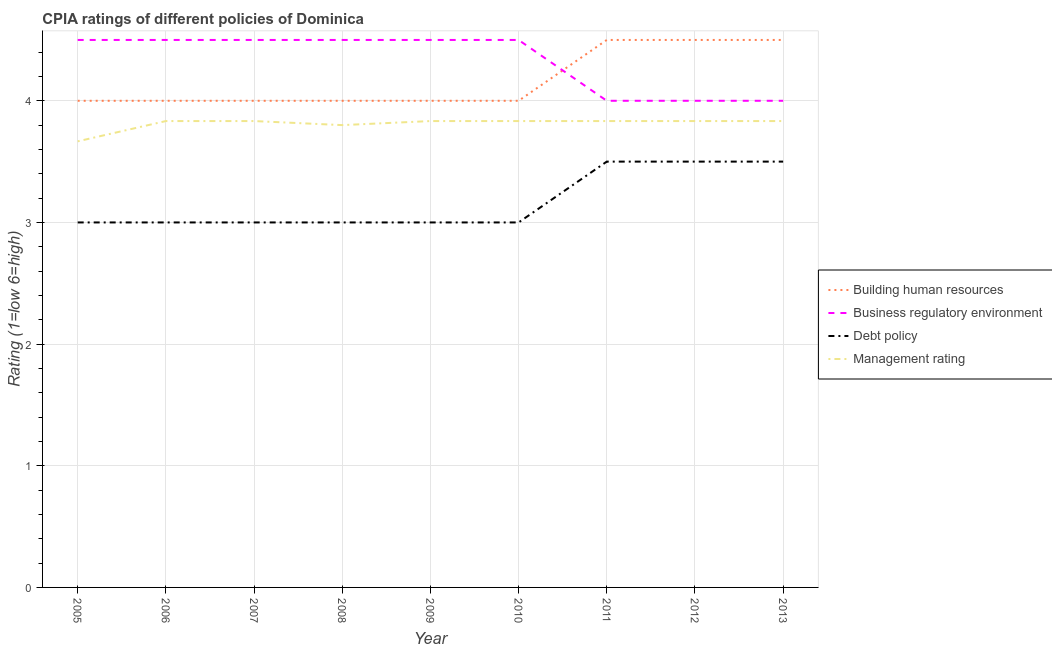Does the line corresponding to cpia rating of management intersect with the line corresponding to cpia rating of debt policy?
Offer a very short reply. No. Is the number of lines equal to the number of legend labels?
Provide a succinct answer. Yes. Across all years, what is the minimum cpia rating of business regulatory environment?
Make the answer very short. 4. What is the total cpia rating of building human resources in the graph?
Give a very brief answer. 37.5. What is the difference between the cpia rating of management in 2008 and the cpia rating of debt policy in 2013?
Offer a very short reply. 0.3. What is the average cpia rating of management per year?
Your answer should be very brief. 3.81. In the year 2012, what is the difference between the cpia rating of building human resources and cpia rating of management?
Ensure brevity in your answer.  0.67. What is the ratio of the cpia rating of management in 2008 to that in 2011?
Keep it short and to the point. 0.99. Is the cpia rating of debt policy in 2007 less than that in 2008?
Keep it short and to the point. No. Is the difference between the cpia rating of management in 2007 and 2008 greater than the difference between the cpia rating of business regulatory environment in 2007 and 2008?
Offer a very short reply. Yes. Is it the case that in every year, the sum of the cpia rating of debt policy and cpia rating of management is greater than the sum of cpia rating of business regulatory environment and cpia rating of building human resources?
Offer a very short reply. No. Is it the case that in every year, the sum of the cpia rating of building human resources and cpia rating of business regulatory environment is greater than the cpia rating of debt policy?
Give a very brief answer. Yes. Does the cpia rating of business regulatory environment monotonically increase over the years?
Keep it short and to the point. No. Is the cpia rating of management strictly less than the cpia rating of debt policy over the years?
Offer a very short reply. No. How many lines are there?
Your answer should be compact. 4. Does the graph contain any zero values?
Provide a succinct answer. No. Does the graph contain grids?
Your answer should be compact. Yes. Where does the legend appear in the graph?
Offer a terse response. Center right. How many legend labels are there?
Provide a short and direct response. 4. What is the title of the graph?
Ensure brevity in your answer.  CPIA ratings of different policies of Dominica. Does "Austria" appear as one of the legend labels in the graph?
Offer a terse response. No. What is the Rating (1=low 6=high) in Building human resources in 2005?
Ensure brevity in your answer.  4. What is the Rating (1=low 6=high) of Management rating in 2005?
Provide a succinct answer. 3.67. What is the Rating (1=low 6=high) of Management rating in 2006?
Your response must be concise. 3.83. What is the Rating (1=low 6=high) in Debt policy in 2007?
Your answer should be very brief. 3. What is the Rating (1=low 6=high) of Management rating in 2007?
Your answer should be very brief. 3.83. What is the Rating (1=low 6=high) of Building human resources in 2008?
Your answer should be compact. 4. What is the Rating (1=low 6=high) of Debt policy in 2008?
Your answer should be compact. 3. What is the Rating (1=low 6=high) of Business regulatory environment in 2009?
Ensure brevity in your answer.  4.5. What is the Rating (1=low 6=high) in Debt policy in 2009?
Your response must be concise. 3. What is the Rating (1=low 6=high) in Management rating in 2009?
Your response must be concise. 3.83. What is the Rating (1=low 6=high) of Management rating in 2010?
Offer a very short reply. 3.83. What is the Rating (1=low 6=high) in Building human resources in 2011?
Offer a very short reply. 4.5. What is the Rating (1=low 6=high) in Management rating in 2011?
Offer a very short reply. 3.83. What is the Rating (1=low 6=high) in Building human resources in 2012?
Ensure brevity in your answer.  4.5. What is the Rating (1=low 6=high) of Management rating in 2012?
Your answer should be compact. 3.83. What is the Rating (1=low 6=high) of Debt policy in 2013?
Give a very brief answer. 3.5. What is the Rating (1=low 6=high) in Management rating in 2013?
Your answer should be compact. 3.83. Across all years, what is the maximum Rating (1=low 6=high) of Building human resources?
Provide a short and direct response. 4.5. Across all years, what is the maximum Rating (1=low 6=high) of Management rating?
Provide a short and direct response. 3.83. Across all years, what is the minimum Rating (1=low 6=high) of Building human resources?
Make the answer very short. 4. Across all years, what is the minimum Rating (1=low 6=high) in Debt policy?
Offer a terse response. 3. Across all years, what is the minimum Rating (1=low 6=high) in Management rating?
Ensure brevity in your answer.  3.67. What is the total Rating (1=low 6=high) of Building human resources in the graph?
Ensure brevity in your answer.  37.5. What is the total Rating (1=low 6=high) in Business regulatory environment in the graph?
Provide a short and direct response. 39. What is the total Rating (1=low 6=high) in Debt policy in the graph?
Ensure brevity in your answer.  28.5. What is the total Rating (1=low 6=high) of Management rating in the graph?
Your response must be concise. 34.3. What is the difference between the Rating (1=low 6=high) of Management rating in 2005 and that in 2006?
Your response must be concise. -0.17. What is the difference between the Rating (1=low 6=high) in Building human resources in 2005 and that in 2007?
Your answer should be very brief. 0. What is the difference between the Rating (1=low 6=high) in Building human resources in 2005 and that in 2008?
Your answer should be compact. 0. What is the difference between the Rating (1=low 6=high) of Business regulatory environment in 2005 and that in 2008?
Provide a short and direct response. 0. What is the difference between the Rating (1=low 6=high) of Debt policy in 2005 and that in 2008?
Give a very brief answer. 0. What is the difference between the Rating (1=low 6=high) of Management rating in 2005 and that in 2008?
Your answer should be compact. -0.13. What is the difference between the Rating (1=low 6=high) of Building human resources in 2005 and that in 2009?
Provide a short and direct response. 0. What is the difference between the Rating (1=low 6=high) of Business regulatory environment in 2005 and that in 2009?
Your response must be concise. 0. What is the difference between the Rating (1=low 6=high) of Debt policy in 2005 and that in 2009?
Keep it short and to the point. 0. What is the difference between the Rating (1=low 6=high) in Business regulatory environment in 2005 and that in 2010?
Your answer should be compact. 0. What is the difference between the Rating (1=low 6=high) of Business regulatory environment in 2005 and that in 2011?
Offer a very short reply. 0.5. What is the difference between the Rating (1=low 6=high) of Debt policy in 2005 and that in 2011?
Provide a short and direct response. -0.5. What is the difference between the Rating (1=low 6=high) of Management rating in 2005 and that in 2011?
Offer a very short reply. -0.17. What is the difference between the Rating (1=low 6=high) in Building human resources in 2005 and that in 2012?
Give a very brief answer. -0.5. What is the difference between the Rating (1=low 6=high) in Debt policy in 2005 and that in 2012?
Make the answer very short. -0.5. What is the difference between the Rating (1=low 6=high) in Debt policy in 2005 and that in 2013?
Provide a short and direct response. -0.5. What is the difference between the Rating (1=low 6=high) of Business regulatory environment in 2006 and that in 2007?
Provide a short and direct response. 0. What is the difference between the Rating (1=low 6=high) of Management rating in 2006 and that in 2007?
Offer a terse response. 0. What is the difference between the Rating (1=low 6=high) in Management rating in 2006 and that in 2008?
Offer a terse response. 0.03. What is the difference between the Rating (1=low 6=high) of Management rating in 2006 and that in 2009?
Keep it short and to the point. 0. What is the difference between the Rating (1=low 6=high) of Business regulatory environment in 2006 and that in 2010?
Offer a terse response. 0. What is the difference between the Rating (1=low 6=high) in Debt policy in 2006 and that in 2010?
Ensure brevity in your answer.  0. What is the difference between the Rating (1=low 6=high) in Management rating in 2006 and that in 2010?
Offer a very short reply. 0. What is the difference between the Rating (1=low 6=high) in Debt policy in 2006 and that in 2011?
Provide a short and direct response. -0.5. What is the difference between the Rating (1=low 6=high) in Business regulatory environment in 2006 and that in 2012?
Provide a short and direct response. 0.5. What is the difference between the Rating (1=low 6=high) in Debt policy in 2006 and that in 2012?
Offer a terse response. -0.5. What is the difference between the Rating (1=low 6=high) in Building human resources in 2006 and that in 2013?
Your answer should be compact. -0.5. What is the difference between the Rating (1=low 6=high) of Building human resources in 2007 and that in 2008?
Your response must be concise. 0. What is the difference between the Rating (1=low 6=high) of Business regulatory environment in 2007 and that in 2008?
Your answer should be very brief. 0. What is the difference between the Rating (1=low 6=high) in Debt policy in 2007 and that in 2008?
Provide a short and direct response. 0. What is the difference between the Rating (1=low 6=high) of Building human resources in 2007 and that in 2009?
Make the answer very short. 0. What is the difference between the Rating (1=low 6=high) of Debt policy in 2007 and that in 2009?
Give a very brief answer. 0. What is the difference between the Rating (1=low 6=high) of Management rating in 2007 and that in 2009?
Offer a terse response. 0. What is the difference between the Rating (1=low 6=high) of Building human resources in 2007 and that in 2010?
Your answer should be compact. 0. What is the difference between the Rating (1=low 6=high) of Building human resources in 2007 and that in 2011?
Your answer should be very brief. -0.5. What is the difference between the Rating (1=low 6=high) in Business regulatory environment in 2007 and that in 2013?
Give a very brief answer. 0.5. What is the difference between the Rating (1=low 6=high) in Debt policy in 2007 and that in 2013?
Provide a short and direct response. -0.5. What is the difference between the Rating (1=low 6=high) of Management rating in 2007 and that in 2013?
Your answer should be compact. 0. What is the difference between the Rating (1=low 6=high) of Debt policy in 2008 and that in 2009?
Ensure brevity in your answer.  0. What is the difference between the Rating (1=low 6=high) of Management rating in 2008 and that in 2009?
Your answer should be compact. -0.03. What is the difference between the Rating (1=low 6=high) in Business regulatory environment in 2008 and that in 2010?
Keep it short and to the point. 0. What is the difference between the Rating (1=low 6=high) in Debt policy in 2008 and that in 2010?
Make the answer very short. 0. What is the difference between the Rating (1=low 6=high) in Management rating in 2008 and that in 2010?
Provide a succinct answer. -0.03. What is the difference between the Rating (1=low 6=high) in Management rating in 2008 and that in 2011?
Ensure brevity in your answer.  -0.03. What is the difference between the Rating (1=low 6=high) of Management rating in 2008 and that in 2012?
Provide a succinct answer. -0.03. What is the difference between the Rating (1=low 6=high) in Building human resources in 2008 and that in 2013?
Make the answer very short. -0.5. What is the difference between the Rating (1=low 6=high) in Management rating in 2008 and that in 2013?
Offer a very short reply. -0.03. What is the difference between the Rating (1=low 6=high) of Business regulatory environment in 2009 and that in 2010?
Provide a short and direct response. 0. What is the difference between the Rating (1=low 6=high) of Management rating in 2009 and that in 2010?
Ensure brevity in your answer.  0. What is the difference between the Rating (1=low 6=high) of Building human resources in 2009 and that in 2011?
Provide a succinct answer. -0.5. What is the difference between the Rating (1=low 6=high) in Business regulatory environment in 2009 and that in 2011?
Provide a short and direct response. 0.5. What is the difference between the Rating (1=low 6=high) of Debt policy in 2009 and that in 2011?
Provide a succinct answer. -0.5. What is the difference between the Rating (1=low 6=high) in Building human resources in 2009 and that in 2012?
Make the answer very short. -0.5. What is the difference between the Rating (1=low 6=high) in Debt policy in 2009 and that in 2012?
Ensure brevity in your answer.  -0.5. What is the difference between the Rating (1=low 6=high) of Building human resources in 2009 and that in 2013?
Provide a succinct answer. -0.5. What is the difference between the Rating (1=low 6=high) of Management rating in 2009 and that in 2013?
Offer a terse response. 0. What is the difference between the Rating (1=low 6=high) of Building human resources in 2010 and that in 2011?
Ensure brevity in your answer.  -0.5. What is the difference between the Rating (1=low 6=high) in Business regulatory environment in 2010 and that in 2011?
Provide a succinct answer. 0.5. What is the difference between the Rating (1=low 6=high) in Management rating in 2010 and that in 2011?
Give a very brief answer. 0. What is the difference between the Rating (1=low 6=high) of Building human resources in 2010 and that in 2012?
Your response must be concise. -0.5. What is the difference between the Rating (1=low 6=high) in Debt policy in 2010 and that in 2012?
Give a very brief answer. -0.5. What is the difference between the Rating (1=low 6=high) in Business regulatory environment in 2010 and that in 2013?
Your response must be concise. 0.5. What is the difference between the Rating (1=low 6=high) in Debt policy in 2010 and that in 2013?
Your response must be concise. -0.5. What is the difference between the Rating (1=low 6=high) in Building human resources in 2011 and that in 2012?
Provide a succinct answer. 0. What is the difference between the Rating (1=low 6=high) of Management rating in 2011 and that in 2012?
Offer a terse response. 0. What is the difference between the Rating (1=low 6=high) in Building human resources in 2005 and the Rating (1=low 6=high) in Debt policy in 2006?
Provide a short and direct response. 1. What is the difference between the Rating (1=low 6=high) of Business regulatory environment in 2005 and the Rating (1=low 6=high) of Debt policy in 2006?
Provide a succinct answer. 1.5. What is the difference between the Rating (1=low 6=high) in Business regulatory environment in 2005 and the Rating (1=low 6=high) in Management rating in 2006?
Make the answer very short. 0.67. What is the difference between the Rating (1=low 6=high) of Building human resources in 2005 and the Rating (1=low 6=high) of Business regulatory environment in 2007?
Offer a terse response. -0.5. What is the difference between the Rating (1=low 6=high) in Business regulatory environment in 2005 and the Rating (1=low 6=high) in Debt policy in 2007?
Give a very brief answer. 1.5. What is the difference between the Rating (1=low 6=high) in Business regulatory environment in 2005 and the Rating (1=low 6=high) in Management rating in 2007?
Offer a very short reply. 0.67. What is the difference between the Rating (1=low 6=high) of Building human resources in 2005 and the Rating (1=low 6=high) of Debt policy in 2008?
Provide a short and direct response. 1. What is the difference between the Rating (1=low 6=high) in Building human resources in 2005 and the Rating (1=low 6=high) in Management rating in 2008?
Your answer should be very brief. 0.2. What is the difference between the Rating (1=low 6=high) of Business regulatory environment in 2005 and the Rating (1=low 6=high) of Management rating in 2008?
Give a very brief answer. 0.7. What is the difference between the Rating (1=low 6=high) of Building human resources in 2005 and the Rating (1=low 6=high) of Debt policy in 2009?
Provide a short and direct response. 1. What is the difference between the Rating (1=low 6=high) of Business regulatory environment in 2005 and the Rating (1=low 6=high) of Debt policy in 2009?
Ensure brevity in your answer.  1.5. What is the difference between the Rating (1=low 6=high) of Business regulatory environment in 2005 and the Rating (1=low 6=high) of Debt policy in 2010?
Provide a short and direct response. 1.5. What is the difference between the Rating (1=low 6=high) in Debt policy in 2005 and the Rating (1=low 6=high) in Management rating in 2010?
Offer a very short reply. -0.83. What is the difference between the Rating (1=low 6=high) of Building human resources in 2005 and the Rating (1=low 6=high) of Business regulatory environment in 2011?
Ensure brevity in your answer.  0. What is the difference between the Rating (1=low 6=high) of Building human resources in 2005 and the Rating (1=low 6=high) of Debt policy in 2011?
Provide a succinct answer. 0.5. What is the difference between the Rating (1=low 6=high) in Building human resources in 2005 and the Rating (1=low 6=high) in Management rating in 2011?
Your answer should be compact. 0.17. What is the difference between the Rating (1=low 6=high) of Business regulatory environment in 2005 and the Rating (1=low 6=high) of Management rating in 2011?
Your answer should be compact. 0.67. What is the difference between the Rating (1=low 6=high) in Debt policy in 2005 and the Rating (1=low 6=high) in Management rating in 2011?
Your answer should be very brief. -0.83. What is the difference between the Rating (1=low 6=high) in Building human resources in 2005 and the Rating (1=low 6=high) in Management rating in 2012?
Keep it short and to the point. 0.17. What is the difference between the Rating (1=low 6=high) in Business regulatory environment in 2005 and the Rating (1=low 6=high) in Debt policy in 2012?
Offer a terse response. 1. What is the difference between the Rating (1=low 6=high) in Business regulatory environment in 2005 and the Rating (1=low 6=high) in Management rating in 2012?
Provide a short and direct response. 0.67. What is the difference between the Rating (1=low 6=high) in Building human resources in 2005 and the Rating (1=low 6=high) in Business regulatory environment in 2013?
Offer a terse response. 0. What is the difference between the Rating (1=low 6=high) in Building human resources in 2005 and the Rating (1=low 6=high) in Management rating in 2013?
Provide a succinct answer. 0.17. What is the difference between the Rating (1=low 6=high) in Business regulatory environment in 2005 and the Rating (1=low 6=high) in Debt policy in 2013?
Ensure brevity in your answer.  1. What is the difference between the Rating (1=low 6=high) of Business regulatory environment in 2005 and the Rating (1=low 6=high) of Management rating in 2013?
Make the answer very short. 0.67. What is the difference between the Rating (1=low 6=high) in Building human resources in 2006 and the Rating (1=low 6=high) in Business regulatory environment in 2007?
Ensure brevity in your answer.  -0.5. What is the difference between the Rating (1=low 6=high) of Building human resources in 2006 and the Rating (1=low 6=high) of Debt policy in 2007?
Ensure brevity in your answer.  1. What is the difference between the Rating (1=low 6=high) in Debt policy in 2006 and the Rating (1=low 6=high) in Management rating in 2007?
Your response must be concise. -0.83. What is the difference between the Rating (1=low 6=high) in Business regulatory environment in 2006 and the Rating (1=low 6=high) in Management rating in 2008?
Ensure brevity in your answer.  0.7. What is the difference between the Rating (1=low 6=high) of Debt policy in 2006 and the Rating (1=low 6=high) of Management rating in 2008?
Offer a terse response. -0.8. What is the difference between the Rating (1=low 6=high) in Building human resources in 2006 and the Rating (1=low 6=high) in Business regulatory environment in 2009?
Your answer should be very brief. -0.5. What is the difference between the Rating (1=low 6=high) of Building human resources in 2006 and the Rating (1=low 6=high) of Debt policy in 2009?
Offer a very short reply. 1. What is the difference between the Rating (1=low 6=high) in Building human resources in 2006 and the Rating (1=low 6=high) in Management rating in 2009?
Your answer should be very brief. 0.17. What is the difference between the Rating (1=low 6=high) in Business regulatory environment in 2006 and the Rating (1=low 6=high) in Debt policy in 2009?
Your response must be concise. 1.5. What is the difference between the Rating (1=low 6=high) of Building human resources in 2006 and the Rating (1=low 6=high) of Business regulatory environment in 2010?
Your response must be concise. -0.5. What is the difference between the Rating (1=low 6=high) in Building human resources in 2006 and the Rating (1=low 6=high) in Debt policy in 2010?
Ensure brevity in your answer.  1. What is the difference between the Rating (1=low 6=high) in Business regulatory environment in 2006 and the Rating (1=low 6=high) in Debt policy in 2010?
Ensure brevity in your answer.  1.5. What is the difference between the Rating (1=low 6=high) in Debt policy in 2006 and the Rating (1=low 6=high) in Management rating in 2010?
Keep it short and to the point. -0.83. What is the difference between the Rating (1=low 6=high) in Building human resources in 2006 and the Rating (1=low 6=high) in Business regulatory environment in 2011?
Your answer should be very brief. 0. What is the difference between the Rating (1=low 6=high) of Building human resources in 2006 and the Rating (1=low 6=high) of Debt policy in 2011?
Provide a succinct answer. 0.5. What is the difference between the Rating (1=low 6=high) of Building human resources in 2006 and the Rating (1=low 6=high) of Management rating in 2011?
Your answer should be compact. 0.17. What is the difference between the Rating (1=low 6=high) in Business regulatory environment in 2006 and the Rating (1=low 6=high) in Management rating in 2011?
Provide a succinct answer. 0.67. What is the difference between the Rating (1=low 6=high) of Debt policy in 2006 and the Rating (1=low 6=high) of Management rating in 2011?
Make the answer very short. -0.83. What is the difference between the Rating (1=low 6=high) of Building human resources in 2006 and the Rating (1=low 6=high) of Business regulatory environment in 2012?
Offer a very short reply. 0. What is the difference between the Rating (1=low 6=high) in Business regulatory environment in 2006 and the Rating (1=low 6=high) in Management rating in 2012?
Make the answer very short. 0.67. What is the difference between the Rating (1=low 6=high) of Debt policy in 2006 and the Rating (1=low 6=high) of Management rating in 2012?
Provide a short and direct response. -0.83. What is the difference between the Rating (1=low 6=high) of Building human resources in 2006 and the Rating (1=low 6=high) of Debt policy in 2013?
Keep it short and to the point. 0.5. What is the difference between the Rating (1=low 6=high) of Building human resources in 2006 and the Rating (1=low 6=high) of Management rating in 2013?
Your response must be concise. 0.17. What is the difference between the Rating (1=low 6=high) in Business regulatory environment in 2006 and the Rating (1=low 6=high) in Debt policy in 2013?
Provide a short and direct response. 1. What is the difference between the Rating (1=low 6=high) of Debt policy in 2006 and the Rating (1=low 6=high) of Management rating in 2013?
Offer a terse response. -0.83. What is the difference between the Rating (1=low 6=high) of Building human resources in 2007 and the Rating (1=low 6=high) of Business regulatory environment in 2008?
Offer a terse response. -0.5. What is the difference between the Rating (1=low 6=high) of Building human resources in 2007 and the Rating (1=low 6=high) of Debt policy in 2008?
Your response must be concise. 1. What is the difference between the Rating (1=low 6=high) in Business regulatory environment in 2007 and the Rating (1=low 6=high) in Debt policy in 2008?
Provide a short and direct response. 1.5. What is the difference between the Rating (1=low 6=high) of Debt policy in 2007 and the Rating (1=low 6=high) of Management rating in 2008?
Provide a short and direct response. -0.8. What is the difference between the Rating (1=low 6=high) of Business regulatory environment in 2007 and the Rating (1=low 6=high) of Management rating in 2009?
Your answer should be compact. 0.67. What is the difference between the Rating (1=low 6=high) in Building human resources in 2007 and the Rating (1=low 6=high) in Debt policy in 2010?
Your answer should be compact. 1. What is the difference between the Rating (1=low 6=high) of Building human resources in 2007 and the Rating (1=low 6=high) of Management rating in 2010?
Keep it short and to the point. 0.17. What is the difference between the Rating (1=low 6=high) of Business regulatory environment in 2007 and the Rating (1=low 6=high) of Debt policy in 2010?
Give a very brief answer. 1.5. What is the difference between the Rating (1=low 6=high) of Business regulatory environment in 2007 and the Rating (1=low 6=high) of Management rating in 2010?
Your response must be concise. 0.67. What is the difference between the Rating (1=low 6=high) of Debt policy in 2007 and the Rating (1=low 6=high) of Management rating in 2010?
Ensure brevity in your answer.  -0.83. What is the difference between the Rating (1=low 6=high) in Building human resources in 2007 and the Rating (1=low 6=high) in Debt policy in 2011?
Keep it short and to the point. 0.5. What is the difference between the Rating (1=low 6=high) in Building human resources in 2007 and the Rating (1=low 6=high) in Management rating in 2011?
Offer a very short reply. 0.17. What is the difference between the Rating (1=low 6=high) of Business regulatory environment in 2007 and the Rating (1=low 6=high) of Debt policy in 2011?
Give a very brief answer. 1. What is the difference between the Rating (1=low 6=high) of Debt policy in 2007 and the Rating (1=low 6=high) of Management rating in 2011?
Make the answer very short. -0.83. What is the difference between the Rating (1=low 6=high) in Building human resources in 2007 and the Rating (1=low 6=high) in Business regulatory environment in 2012?
Your response must be concise. 0. What is the difference between the Rating (1=low 6=high) of Building human resources in 2007 and the Rating (1=low 6=high) of Management rating in 2012?
Give a very brief answer. 0.17. What is the difference between the Rating (1=low 6=high) in Business regulatory environment in 2007 and the Rating (1=low 6=high) in Debt policy in 2012?
Make the answer very short. 1. What is the difference between the Rating (1=low 6=high) in Business regulatory environment in 2007 and the Rating (1=low 6=high) in Management rating in 2012?
Offer a very short reply. 0.67. What is the difference between the Rating (1=low 6=high) of Building human resources in 2007 and the Rating (1=low 6=high) of Business regulatory environment in 2013?
Your response must be concise. 0. What is the difference between the Rating (1=low 6=high) in Building human resources in 2007 and the Rating (1=low 6=high) in Debt policy in 2013?
Offer a terse response. 0.5. What is the difference between the Rating (1=low 6=high) of Building human resources in 2007 and the Rating (1=low 6=high) of Management rating in 2013?
Your answer should be compact. 0.17. What is the difference between the Rating (1=low 6=high) in Business regulatory environment in 2007 and the Rating (1=low 6=high) in Management rating in 2013?
Your answer should be compact. 0.67. What is the difference between the Rating (1=low 6=high) in Debt policy in 2007 and the Rating (1=low 6=high) in Management rating in 2013?
Your answer should be very brief. -0.83. What is the difference between the Rating (1=low 6=high) of Building human resources in 2008 and the Rating (1=low 6=high) of Management rating in 2009?
Give a very brief answer. 0.17. What is the difference between the Rating (1=low 6=high) of Business regulatory environment in 2008 and the Rating (1=low 6=high) of Management rating in 2009?
Your answer should be compact. 0.67. What is the difference between the Rating (1=low 6=high) in Building human resources in 2008 and the Rating (1=low 6=high) in Management rating in 2010?
Your answer should be compact. 0.17. What is the difference between the Rating (1=low 6=high) in Business regulatory environment in 2008 and the Rating (1=low 6=high) in Debt policy in 2010?
Give a very brief answer. 1.5. What is the difference between the Rating (1=low 6=high) of Business regulatory environment in 2008 and the Rating (1=low 6=high) of Management rating in 2010?
Offer a very short reply. 0.67. What is the difference between the Rating (1=low 6=high) in Building human resources in 2008 and the Rating (1=low 6=high) in Management rating in 2011?
Keep it short and to the point. 0.17. What is the difference between the Rating (1=low 6=high) in Business regulatory environment in 2008 and the Rating (1=low 6=high) in Management rating in 2011?
Your response must be concise. 0.67. What is the difference between the Rating (1=low 6=high) of Debt policy in 2008 and the Rating (1=low 6=high) of Management rating in 2011?
Your answer should be compact. -0.83. What is the difference between the Rating (1=low 6=high) of Building human resources in 2008 and the Rating (1=low 6=high) of Business regulatory environment in 2012?
Offer a very short reply. 0. What is the difference between the Rating (1=low 6=high) of Building human resources in 2008 and the Rating (1=low 6=high) of Management rating in 2012?
Ensure brevity in your answer.  0.17. What is the difference between the Rating (1=low 6=high) of Business regulatory environment in 2008 and the Rating (1=low 6=high) of Management rating in 2012?
Provide a succinct answer. 0.67. What is the difference between the Rating (1=low 6=high) of Building human resources in 2008 and the Rating (1=low 6=high) of Debt policy in 2013?
Offer a terse response. 0.5. What is the difference between the Rating (1=low 6=high) of Building human resources in 2008 and the Rating (1=low 6=high) of Management rating in 2013?
Make the answer very short. 0.17. What is the difference between the Rating (1=low 6=high) in Business regulatory environment in 2008 and the Rating (1=low 6=high) in Management rating in 2013?
Your answer should be very brief. 0.67. What is the difference between the Rating (1=low 6=high) of Debt policy in 2008 and the Rating (1=low 6=high) of Management rating in 2013?
Offer a very short reply. -0.83. What is the difference between the Rating (1=low 6=high) of Building human resources in 2009 and the Rating (1=low 6=high) of Debt policy in 2010?
Make the answer very short. 1. What is the difference between the Rating (1=low 6=high) of Building human resources in 2009 and the Rating (1=low 6=high) of Management rating in 2010?
Keep it short and to the point. 0.17. What is the difference between the Rating (1=low 6=high) in Business regulatory environment in 2009 and the Rating (1=low 6=high) in Debt policy in 2010?
Your response must be concise. 1.5. What is the difference between the Rating (1=low 6=high) in Business regulatory environment in 2009 and the Rating (1=low 6=high) in Management rating in 2010?
Your response must be concise. 0.67. What is the difference between the Rating (1=low 6=high) in Debt policy in 2009 and the Rating (1=low 6=high) in Management rating in 2010?
Offer a terse response. -0.83. What is the difference between the Rating (1=low 6=high) of Building human resources in 2009 and the Rating (1=low 6=high) of Business regulatory environment in 2011?
Your response must be concise. 0. What is the difference between the Rating (1=low 6=high) in Building human resources in 2009 and the Rating (1=low 6=high) in Debt policy in 2011?
Provide a short and direct response. 0.5. What is the difference between the Rating (1=low 6=high) of Building human resources in 2009 and the Rating (1=low 6=high) of Management rating in 2011?
Offer a very short reply. 0.17. What is the difference between the Rating (1=low 6=high) in Business regulatory environment in 2009 and the Rating (1=low 6=high) in Management rating in 2011?
Your response must be concise. 0.67. What is the difference between the Rating (1=low 6=high) of Debt policy in 2009 and the Rating (1=low 6=high) of Management rating in 2011?
Your response must be concise. -0.83. What is the difference between the Rating (1=low 6=high) of Building human resources in 2009 and the Rating (1=low 6=high) of Management rating in 2012?
Offer a very short reply. 0.17. What is the difference between the Rating (1=low 6=high) in Debt policy in 2009 and the Rating (1=low 6=high) in Management rating in 2012?
Ensure brevity in your answer.  -0.83. What is the difference between the Rating (1=low 6=high) of Building human resources in 2009 and the Rating (1=low 6=high) of Debt policy in 2013?
Your response must be concise. 0.5. What is the difference between the Rating (1=low 6=high) of Business regulatory environment in 2009 and the Rating (1=low 6=high) of Debt policy in 2013?
Offer a terse response. 1. What is the difference between the Rating (1=low 6=high) of Building human resources in 2010 and the Rating (1=low 6=high) of Business regulatory environment in 2011?
Your answer should be compact. 0. What is the difference between the Rating (1=low 6=high) in Building human resources in 2010 and the Rating (1=low 6=high) in Debt policy in 2011?
Your answer should be compact. 0.5. What is the difference between the Rating (1=low 6=high) of Building human resources in 2010 and the Rating (1=low 6=high) of Management rating in 2011?
Give a very brief answer. 0.17. What is the difference between the Rating (1=low 6=high) in Business regulatory environment in 2010 and the Rating (1=low 6=high) in Management rating in 2011?
Keep it short and to the point. 0.67. What is the difference between the Rating (1=low 6=high) in Debt policy in 2010 and the Rating (1=low 6=high) in Management rating in 2011?
Your response must be concise. -0.83. What is the difference between the Rating (1=low 6=high) of Building human resources in 2010 and the Rating (1=low 6=high) of Business regulatory environment in 2012?
Make the answer very short. 0. What is the difference between the Rating (1=low 6=high) of Building human resources in 2010 and the Rating (1=low 6=high) of Debt policy in 2012?
Offer a very short reply. 0.5. What is the difference between the Rating (1=low 6=high) of Building human resources in 2010 and the Rating (1=low 6=high) of Management rating in 2012?
Give a very brief answer. 0.17. What is the difference between the Rating (1=low 6=high) of Business regulatory environment in 2010 and the Rating (1=low 6=high) of Debt policy in 2012?
Offer a terse response. 1. What is the difference between the Rating (1=low 6=high) of Debt policy in 2010 and the Rating (1=low 6=high) of Management rating in 2012?
Offer a very short reply. -0.83. What is the difference between the Rating (1=low 6=high) of Building human resources in 2010 and the Rating (1=low 6=high) of Management rating in 2013?
Give a very brief answer. 0.17. What is the difference between the Rating (1=low 6=high) in Business regulatory environment in 2011 and the Rating (1=low 6=high) in Debt policy in 2012?
Make the answer very short. 0.5. What is the difference between the Rating (1=low 6=high) in Debt policy in 2011 and the Rating (1=low 6=high) in Management rating in 2012?
Ensure brevity in your answer.  -0.33. What is the difference between the Rating (1=low 6=high) of Building human resources in 2011 and the Rating (1=low 6=high) of Business regulatory environment in 2013?
Provide a short and direct response. 0.5. What is the difference between the Rating (1=low 6=high) in Building human resources in 2011 and the Rating (1=low 6=high) in Management rating in 2013?
Keep it short and to the point. 0.67. What is the difference between the Rating (1=low 6=high) of Business regulatory environment in 2011 and the Rating (1=low 6=high) of Management rating in 2013?
Your response must be concise. 0.17. What is the difference between the Rating (1=low 6=high) of Debt policy in 2011 and the Rating (1=low 6=high) of Management rating in 2013?
Make the answer very short. -0.33. What is the difference between the Rating (1=low 6=high) in Building human resources in 2012 and the Rating (1=low 6=high) in Business regulatory environment in 2013?
Your answer should be compact. 0.5. What is the difference between the Rating (1=low 6=high) in Building human resources in 2012 and the Rating (1=low 6=high) in Management rating in 2013?
Ensure brevity in your answer.  0.67. What is the difference between the Rating (1=low 6=high) in Business regulatory environment in 2012 and the Rating (1=low 6=high) in Debt policy in 2013?
Provide a succinct answer. 0.5. What is the difference between the Rating (1=low 6=high) of Debt policy in 2012 and the Rating (1=low 6=high) of Management rating in 2013?
Your response must be concise. -0.33. What is the average Rating (1=low 6=high) of Building human resources per year?
Give a very brief answer. 4.17. What is the average Rating (1=low 6=high) of Business regulatory environment per year?
Keep it short and to the point. 4.33. What is the average Rating (1=low 6=high) in Debt policy per year?
Provide a succinct answer. 3.17. What is the average Rating (1=low 6=high) in Management rating per year?
Give a very brief answer. 3.81. In the year 2005, what is the difference between the Rating (1=low 6=high) in Business regulatory environment and Rating (1=low 6=high) in Management rating?
Give a very brief answer. 0.83. In the year 2005, what is the difference between the Rating (1=low 6=high) in Debt policy and Rating (1=low 6=high) in Management rating?
Your response must be concise. -0.67. In the year 2006, what is the difference between the Rating (1=low 6=high) of Building human resources and Rating (1=low 6=high) of Management rating?
Your answer should be compact. 0.17. In the year 2007, what is the difference between the Rating (1=low 6=high) of Building human resources and Rating (1=low 6=high) of Debt policy?
Your response must be concise. 1. In the year 2007, what is the difference between the Rating (1=low 6=high) in Building human resources and Rating (1=low 6=high) in Management rating?
Provide a succinct answer. 0.17. In the year 2007, what is the difference between the Rating (1=low 6=high) of Debt policy and Rating (1=low 6=high) of Management rating?
Your answer should be compact. -0.83. In the year 2008, what is the difference between the Rating (1=low 6=high) in Building human resources and Rating (1=low 6=high) in Business regulatory environment?
Your answer should be compact. -0.5. In the year 2008, what is the difference between the Rating (1=low 6=high) of Business regulatory environment and Rating (1=low 6=high) of Debt policy?
Provide a short and direct response. 1.5. In the year 2008, what is the difference between the Rating (1=low 6=high) in Debt policy and Rating (1=low 6=high) in Management rating?
Your answer should be very brief. -0.8. In the year 2009, what is the difference between the Rating (1=low 6=high) of Building human resources and Rating (1=low 6=high) of Debt policy?
Offer a terse response. 1. In the year 2009, what is the difference between the Rating (1=low 6=high) in Building human resources and Rating (1=low 6=high) in Management rating?
Your response must be concise. 0.17. In the year 2009, what is the difference between the Rating (1=low 6=high) of Business regulatory environment and Rating (1=low 6=high) of Debt policy?
Offer a terse response. 1.5. In the year 2009, what is the difference between the Rating (1=low 6=high) of Business regulatory environment and Rating (1=low 6=high) of Management rating?
Make the answer very short. 0.67. In the year 2010, what is the difference between the Rating (1=low 6=high) of Building human resources and Rating (1=low 6=high) of Management rating?
Keep it short and to the point. 0.17. In the year 2010, what is the difference between the Rating (1=low 6=high) in Business regulatory environment and Rating (1=low 6=high) in Debt policy?
Provide a succinct answer. 1.5. In the year 2010, what is the difference between the Rating (1=low 6=high) of Business regulatory environment and Rating (1=low 6=high) of Management rating?
Provide a succinct answer. 0.67. In the year 2010, what is the difference between the Rating (1=low 6=high) of Debt policy and Rating (1=low 6=high) of Management rating?
Your answer should be very brief. -0.83. In the year 2011, what is the difference between the Rating (1=low 6=high) of Business regulatory environment and Rating (1=low 6=high) of Debt policy?
Offer a very short reply. 0.5. In the year 2011, what is the difference between the Rating (1=low 6=high) in Debt policy and Rating (1=low 6=high) in Management rating?
Your response must be concise. -0.33. In the year 2012, what is the difference between the Rating (1=low 6=high) in Building human resources and Rating (1=low 6=high) in Business regulatory environment?
Your answer should be very brief. 0.5. In the year 2012, what is the difference between the Rating (1=low 6=high) in Building human resources and Rating (1=low 6=high) in Debt policy?
Ensure brevity in your answer.  1. In the year 2012, what is the difference between the Rating (1=low 6=high) of Building human resources and Rating (1=low 6=high) of Management rating?
Provide a succinct answer. 0.67. In the year 2012, what is the difference between the Rating (1=low 6=high) in Business regulatory environment and Rating (1=low 6=high) in Debt policy?
Your answer should be very brief. 0.5. In the year 2013, what is the difference between the Rating (1=low 6=high) in Building human resources and Rating (1=low 6=high) in Business regulatory environment?
Give a very brief answer. 0.5. In the year 2013, what is the difference between the Rating (1=low 6=high) of Building human resources and Rating (1=low 6=high) of Management rating?
Provide a short and direct response. 0.67. In the year 2013, what is the difference between the Rating (1=low 6=high) of Business regulatory environment and Rating (1=low 6=high) of Debt policy?
Your response must be concise. 0.5. In the year 2013, what is the difference between the Rating (1=low 6=high) of Business regulatory environment and Rating (1=low 6=high) of Management rating?
Your answer should be very brief. 0.17. In the year 2013, what is the difference between the Rating (1=low 6=high) of Debt policy and Rating (1=low 6=high) of Management rating?
Your answer should be compact. -0.33. What is the ratio of the Rating (1=low 6=high) of Building human resources in 2005 to that in 2006?
Your response must be concise. 1. What is the ratio of the Rating (1=low 6=high) in Business regulatory environment in 2005 to that in 2006?
Give a very brief answer. 1. What is the ratio of the Rating (1=low 6=high) in Debt policy in 2005 to that in 2006?
Keep it short and to the point. 1. What is the ratio of the Rating (1=low 6=high) in Management rating in 2005 to that in 2006?
Offer a terse response. 0.96. What is the ratio of the Rating (1=low 6=high) of Building human resources in 2005 to that in 2007?
Make the answer very short. 1. What is the ratio of the Rating (1=low 6=high) in Management rating in 2005 to that in 2007?
Provide a short and direct response. 0.96. What is the ratio of the Rating (1=low 6=high) of Business regulatory environment in 2005 to that in 2008?
Offer a terse response. 1. What is the ratio of the Rating (1=low 6=high) of Management rating in 2005 to that in 2008?
Ensure brevity in your answer.  0.96. What is the ratio of the Rating (1=low 6=high) of Building human resources in 2005 to that in 2009?
Make the answer very short. 1. What is the ratio of the Rating (1=low 6=high) in Business regulatory environment in 2005 to that in 2009?
Provide a succinct answer. 1. What is the ratio of the Rating (1=low 6=high) in Management rating in 2005 to that in 2009?
Keep it short and to the point. 0.96. What is the ratio of the Rating (1=low 6=high) of Building human resources in 2005 to that in 2010?
Offer a terse response. 1. What is the ratio of the Rating (1=low 6=high) in Business regulatory environment in 2005 to that in 2010?
Ensure brevity in your answer.  1. What is the ratio of the Rating (1=low 6=high) of Debt policy in 2005 to that in 2010?
Give a very brief answer. 1. What is the ratio of the Rating (1=low 6=high) of Management rating in 2005 to that in 2010?
Your response must be concise. 0.96. What is the ratio of the Rating (1=low 6=high) in Business regulatory environment in 2005 to that in 2011?
Offer a very short reply. 1.12. What is the ratio of the Rating (1=low 6=high) of Management rating in 2005 to that in 2011?
Provide a succinct answer. 0.96. What is the ratio of the Rating (1=low 6=high) of Building human resources in 2005 to that in 2012?
Your response must be concise. 0.89. What is the ratio of the Rating (1=low 6=high) in Business regulatory environment in 2005 to that in 2012?
Offer a terse response. 1.12. What is the ratio of the Rating (1=low 6=high) in Debt policy in 2005 to that in 2012?
Your answer should be very brief. 0.86. What is the ratio of the Rating (1=low 6=high) in Management rating in 2005 to that in 2012?
Ensure brevity in your answer.  0.96. What is the ratio of the Rating (1=low 6=high) of Business regulatory environment in 2005 to that in 2013?
Offer a terse response. 1.12. What is the ratio of the Rating (1=low 6=high) of Debt policy in 2005 to that in 2013?
Provide a short and direct response. 0.86. What is the ratio of the Rating (1=low 6=high) of Management rating in 2005 to that in 2013?
Make the answer very short. 0.96. What is the ratio of the Rating (1=low 6=high) of Building human resources in 2006 to that in 2007?
Give a very brief answer. 1. What is the ratio of the Rating (1=low 6=high) in Business regulatory environment in 2006 to that in 2007?
Keep it short and to the point. 1. What is the ratio of the Rating (1=low 6=high) in Management rating in 2006 to that in 2007?
Your response must be concise. 1. What is the ratio of the Rating (1=low 6=high) of Building human resources in 2006 to that in 2008?
Provide a short and direct response. 1. What is the ratio of the Rating (1=low 6=high) of Debt policy in 2006 to that in 2008?
Keep it short and to the point. 1. What is the ratio of the Rating (1=low 6=high) of Management rating in 2006 to that in 2008?
Offer a terse response. 1.01. What is the ratio of the Rating (1=low 6=high) of Business regulatory environment in 2006 to that in 2009?
Give a very brief answer. 1. What is the ratio of the Rating (1=low 6=high) in Debt policy in 2006 to that in 2010?
Make the answer very short. 1. What is the ratio of the Rating (1=low 6=high) of Building human resources in 2006 to that in 2011?
Offer a terse response. 0.89. What is the ratio of the Rating (1=low 6=high) in Business regulatory environment in 2006 to that in 2011?
Ensure brevity in your answer.  1.12. What is the ratio of the Rating (1=low 6=high) in Debt policy in 2006 to that in 2011?
Give a very brief answer. 0.86. What is the ratio of the Rating (1=low 6=high) of Building human resources in 2006 to that in 2012?
Make the answer very short. 0.89. What is the ratio of the Rating (1=low 6=high) of Business regulatory environment in 2006 to that in 2012?
Your response must be concise. 1.12. What is the ratio of the Rating (1=low 6=high) of Debt policy in 2006 to that in 2012?
Ensure brevity in your answer.  0.86. What is the ratio of the Rating (1=low 6=high) of Business regulatory environment in 2006 to that in 2013?
Your response must be concise. 1.12. What is the ratio of the Rating (1=low 6=high) in Debt policy in 2006 to that in 2013?
Your response must be concise. 0.86. What is the ratio of the Rating (1=low 6=high) in Management rating in 2006 to that in 2013?
Offer a terse response. 1. What is the ratio of the Rating (1=low 6=high) in Debt policy in 2007 to that in 2008?
Give a very brief answer. 1. What is the ratio of the Rating (1=low 6=high) in Management rating in 2007 to that in 2008?
Ensure brevity in your answer.  1.01. What is the ratio of the Rating (1=low 6=high) of Building human resources in 2007 to that in 2009?
Your answer should be compact. 1. What is the ratio of the Rating (1=low 6=high) in Management rating in 2007 to that in 2009?
Ensure brevity in your answer.  1. What is the ratio of the Rating (1=low 6=high) in Building human resources in 2007 to that in 2010?
Your response must be concise. 1. What is the ratio of the Rating (1=low 6=high) of Business regulatory environment in 2007 to that in 2010?
Provide a succinct answer. 1. What is the ratio of the Rating (1=low 6=high) of Debt policy in 2007 to that in 2010?
Offer a terse response. 1. What is the ratio of the Rating (1=low 6=high) of Management rating in 2007 to that in 2010?
Provide a succinct answer. 1. What is the ratio of the Rating (1=low 6=high) in Business regulatory environment in 2007 to that in 2011?
Offer a terse response. 1.12. What is the ratio of the Rating (1=low 6=high) of Management rating in 2007 to that in 2011?
Your response must be concise. 1. What is the ratio of the Rating (1=low 6=high) of Management rating in 2007 to that in 2012?
Your answer should be very brief. 1. What is the ratio of the Rating (1=low 6=high) of Business regulatory environment in 2007 to that in 2013?
Ensure brevity in your answer.  1.12. What is the ratio of the Rating (1=low 6=high) of Debt policy in 2008 to that in 2009?
Give a very brief answer. 1. What is the ratio of the Rating (1=low 6=high) of Management rating in 2008 to that in 2009?
Your answer should be very brief. 0.99. What is the ratio of the Rating (1=low 6=high) in Building human resources in 2008 to that in 2010?
Provide a short and direct response. 1. What is the ratio of the Rating (1=low 6=high) of Business regulatory environment in 2008 to that in 2010?
Provide a short and direct response. 1. What is the ratio of the Rating (1=low 6=high) of Debt policy in 2008 to that in 2012?
Your answer should be very brief. 0.86. What is the ratio of the Rating (1=low 6=high) of Management rating in 2008 to that in 2012?
Ensure brevity in your answer.  0.99. What is the ratio of the Rating (1=low 6=high) of Management rating in 2009 to that in 2010?
Provide a succinct answer. 1. What is the ratio of the Rating (1=low 6=high) in Building human resources in 2009 to that in 2011?
Make the answer very short. 0.89. What is the ratio of the Rating (1=low 6=high) in Business regulatory environment in 2009 to that in 2012?
Make the answer very short. 1.12. What is the ratio of the Rating (1=low 6=high) in Building human resources in 2009 to that in 2013?
Ensure brevity in your answer.  0.89. What is the ratio of the Rating (1=low 6=high) in Debt policy in 2009 to that in 2013?
Make the answer very short. 0.86. What is the ratio of the Rating (1=low 6=high) in Management rating in 2009 to that in 2013?
Offer a very short reply. 1. What is the ratio of the Rating (1=low 6=high) in Building human resources in 2010 to that in 2011?
Keep it short and to the point. 0.89. What is the ratio of the Rating (1=low 6=high) in Business regulatory environment in 2010 to that in 2011?
Provide a succinct answer. 1.12. What is the ratio of the Rating (1=low 6=high) in Debt policy in 2010 to that in 2011?
Keep it short and to the point. 0.86. What is the ratio of the Rating (1=low 6=high) of Business regulatory environment in 2010 to that in 2012?
Give a very brief answer. 1.12. What is the ratio of the Rating (1=low 6=high) of Building human resources in 2010 to that in 2013?
Provide a succinct answer. 0.89. What is the ratio of the Rating (1=low 6=high) of Debt policy in 2010 to that in 2013?
Your answer should be very brief. 0.86. What is the ratio of the Rating (1=low 6=high) of Business regulatory environment in 2011 to that in 2012?
Keep it short and to the point. 1. What is the ratio of the Rating (1=low 6=high) in Debt policy in 2011 to that in 2012?
Offer a terse response. 1. What is the ratio of the Rating (1=low 6=high) in Management rating in 2011 to that in 2012?
Give a very brief answer. 1. What is the ratio of the Rating (1=low 6=high) of Business regulatory environment in 2011 to that in 2013?
Give a very brief answer. 1. What is the ratio of the Rating (1=low 6=high) of Debt policy in 2011 to that in 2013?
Your answer should be compact. 1. What is the ratio of the Rating (1=low 6=high) in Management rating in 2011 to that in 2013?
Provide a succinct answer. 1. What is the ratio of the Rating (1=low 6=high) in Business regulatory environment in 2012 to that in 2013?
Offer a terse response. 1. What is the ratio of the Rating (1=low 6=high) of Management rating in 2012 to that in 2013?
Give a very brief answer. 1. What is the difference between the highest and the second highest Rating (1=low 6=high) in Management rating?
Make the answer very short. 0. What is the difference between the highest and the lowest Rating (1=low 6=high) in Building human resources?
Make the answer very short. 0.5. What is the difference between the highest and the lowest Rating (1=low 6=high) of Debt policy?
Your response must be concise. 0.5. What is the difference between the highest and the lowest Rating (1=low 6=high) in Management rating?
Provide a succinct answer. 0.17. 